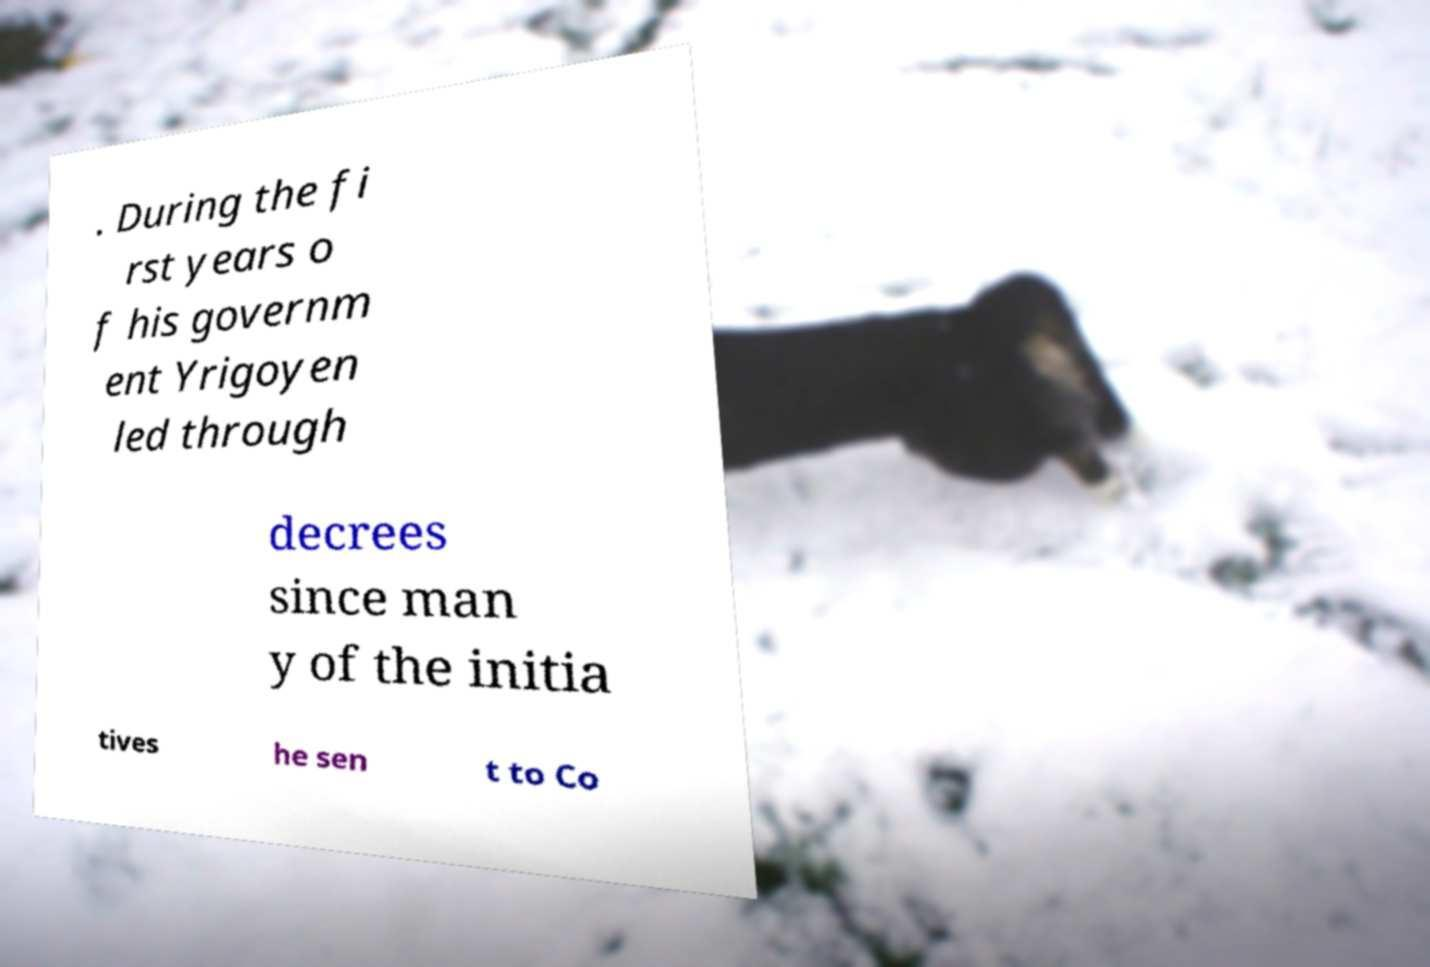Could you extract and type out the text from this image? . During the fi rst years o f his governm ent Yrigoyen led through decrees since man y of the initia tives he sen t to Co 